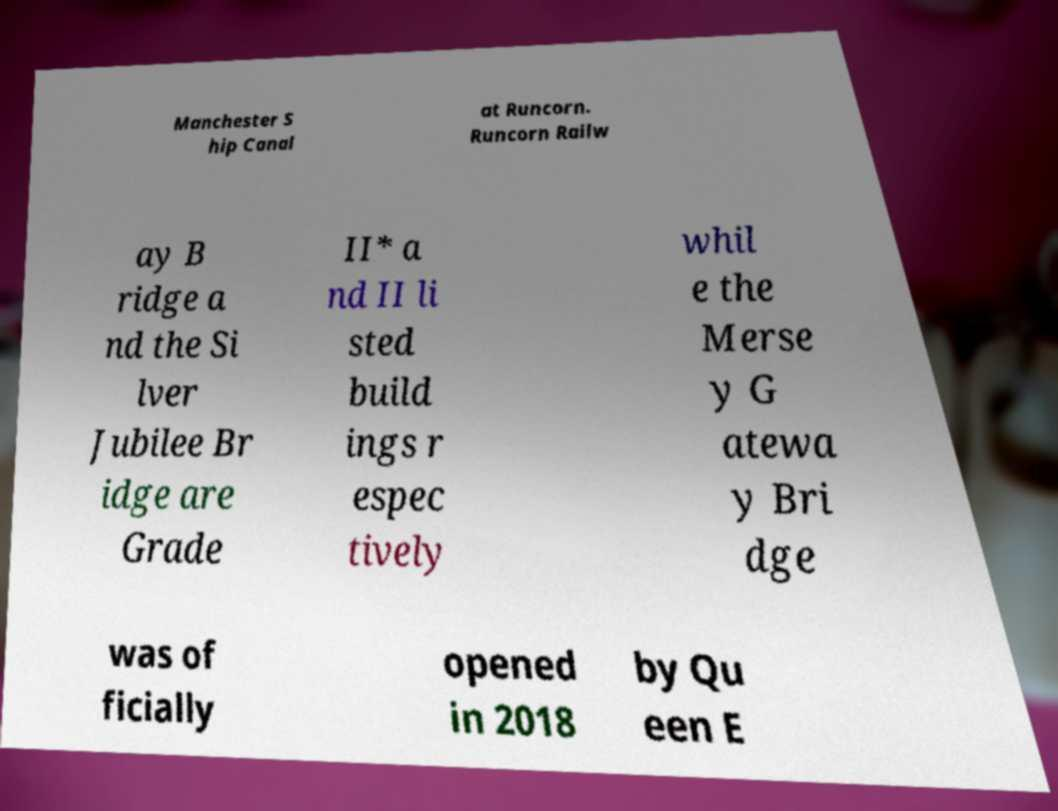Please identify and transcribe the text found in this image. Manchester S hip Canal at Runcorn. Runcorn Railw ay B ridge a nd the Si lver Jubilee Br idge are Grade II* a nd II li sted build ings r espec tively whil e the Merse y G atewa y Bri dge was of ficially opened in 2018 by Qu een E 